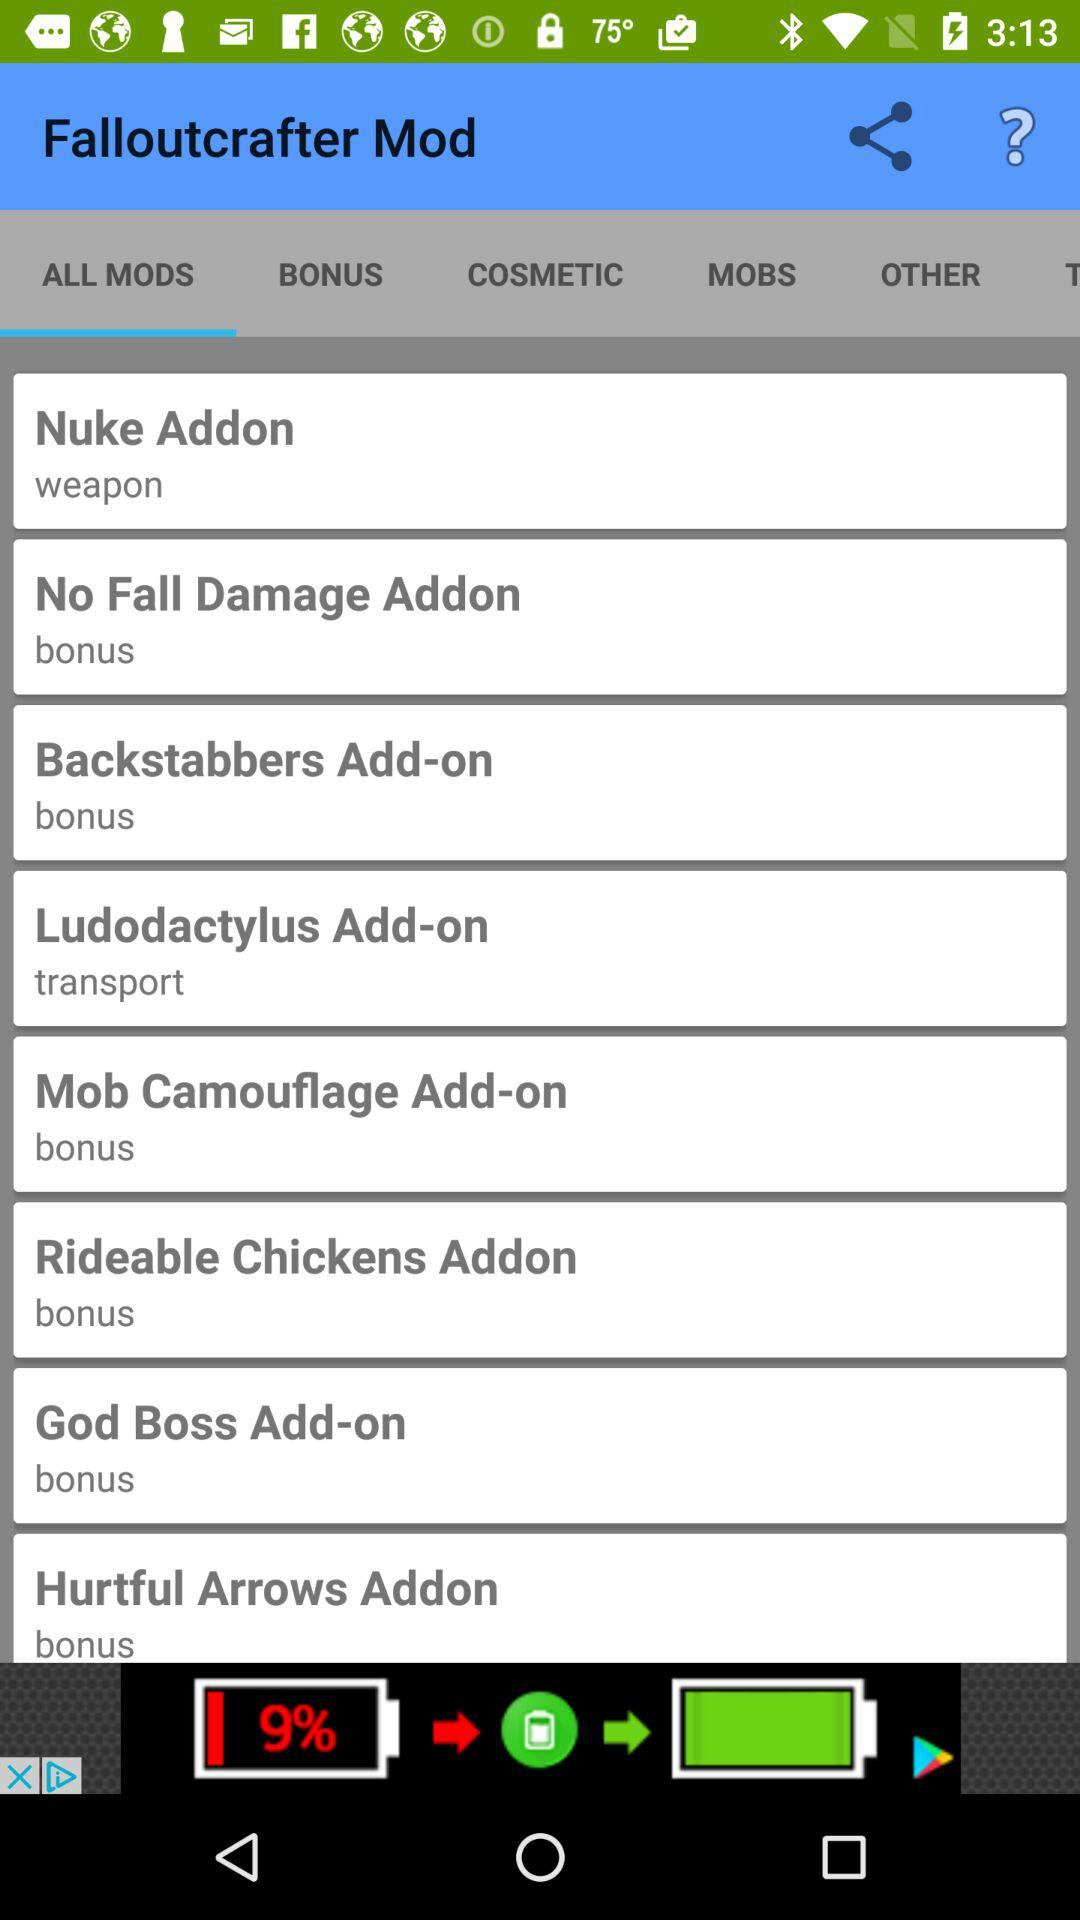How many mods are there in total?
Answer the question using a single word or phrase. 8 